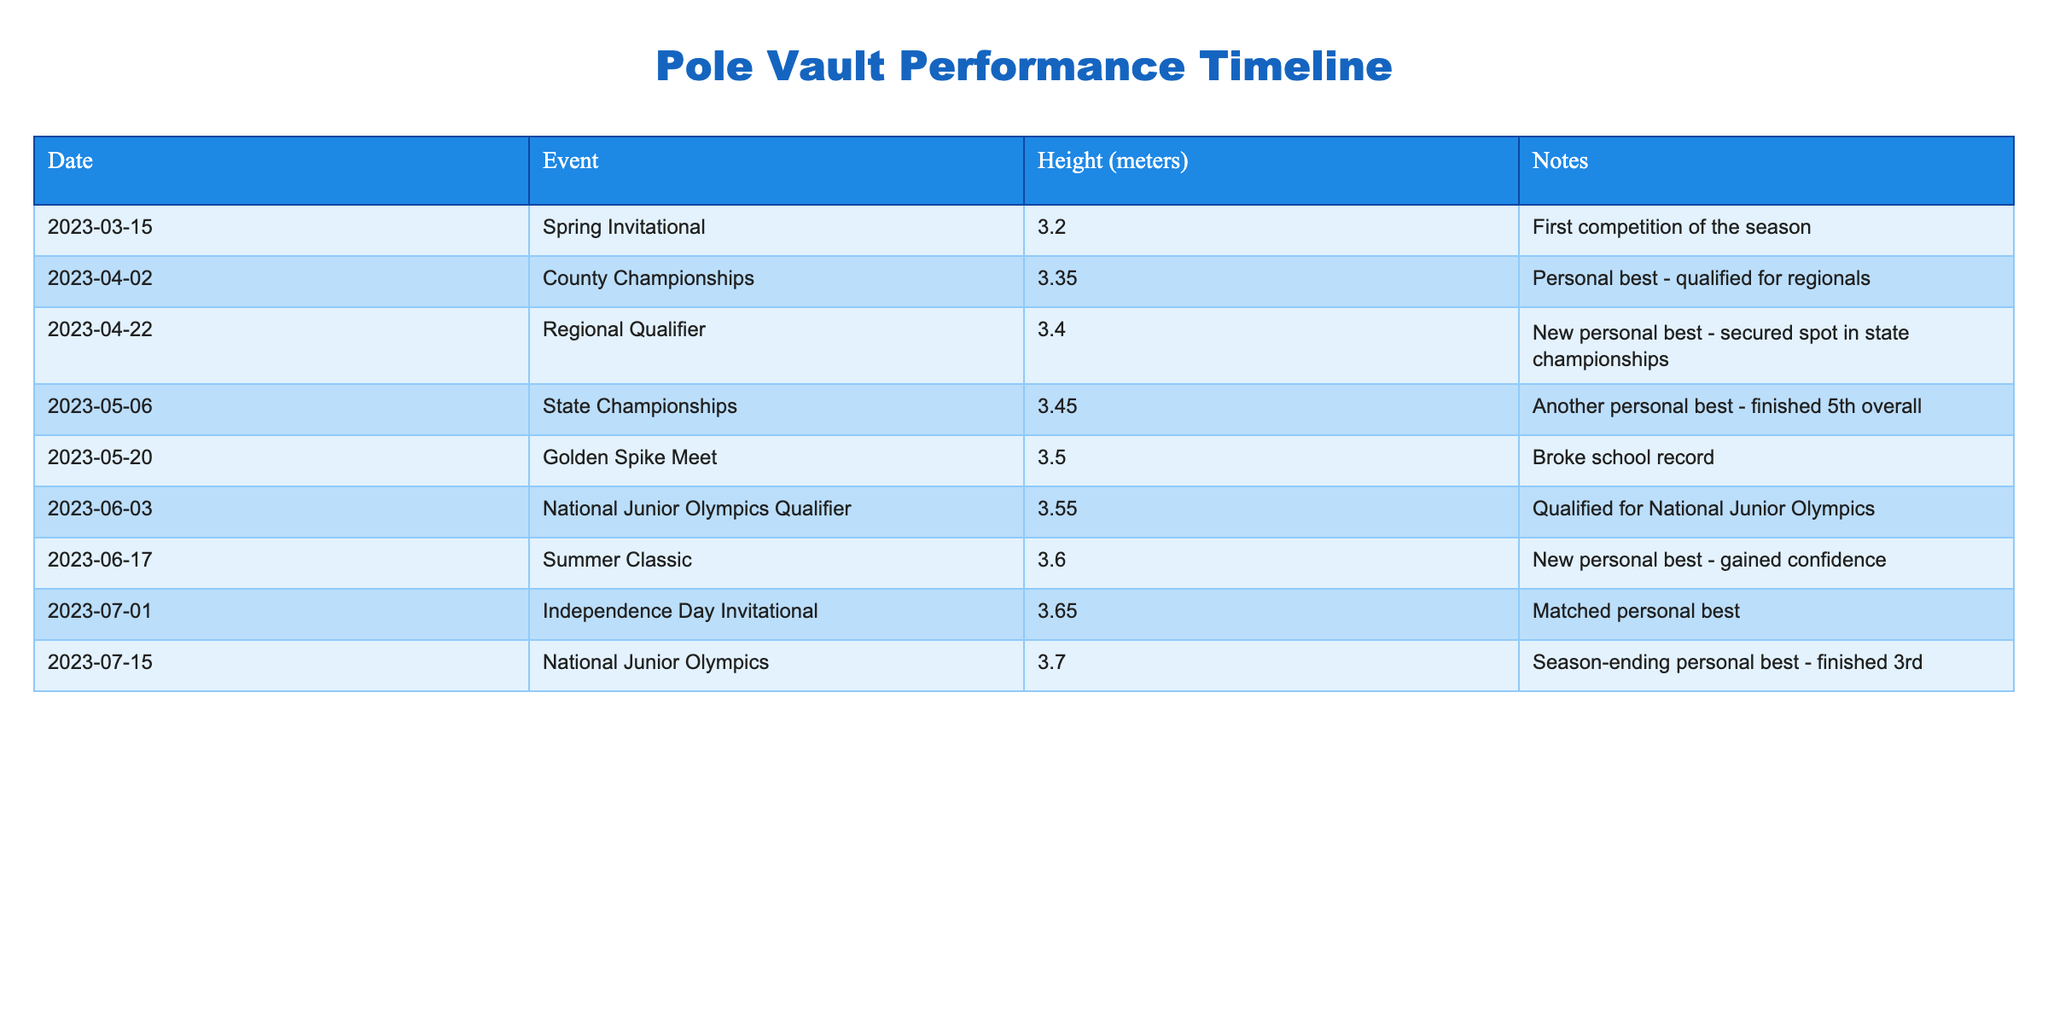What was the highest height achieved in the competitions? The highest height can be found by looking at the "Height (meters)" column. Scanning through the entries, the maximum value is 3.70 meters, which was achieved at the National Junior Olympics.
Answer: 3.70 meters How many personal best heights were recorded during the season? Counting the occurrences of "personal best" mentioned in the "Notes" column, there are four entries that state a personal best: County Championships (3.35), Regional Qualifier (3.40), State Championships (3.45), Summer Classic (3.60), and National Junior Olympics (3.70). So, there are a total of four personal bests.
Answer: 4 What is the difference in height between the first and last recorded competitions? The first competition's height on March 15 was 3.20 meters, and the last competition on July 15 was 3.70 meters. The difference is calculated as 3.70 - 3.20 = 0.50 meters.
Answer: 0.50 meters Did the athlete achieve a new personal best in the Spring Invitational? The Spring Invitational marks the first competition of the season, where the recorded height was 3.20 meters. There is no previous height to compare to, thus a new personal best was not achieved here as it was the initial record.
Answer: No What was the average height achieved across all competitions? To find the average, sum all the heights: (3.20 + 3.35 + 3.40 + 3.45 + 3.50 + 3.55 + 3.60 + 3.65 + 3.70) = 30.50 meters. Divide this sum by the number of competitions (9): 30.50 / 9 = approximately 3.39 meters.
Answer: 3.39 meters Which competition had the second highest height, and what was that height? In the list, the highest height of 3.70 meters was achieved at the National Junior Olympics. The second highest is 3.65 meters, recorded at the Independence Day Invitational.
Answer: Independence Day Invitational, 3.65 meters Was there a competition where the athlete matched their personal best? The table shows that at the Independence Day Invitational, the height of 3.65 meters was recorded as a match to a previous personal best, achieved earlier in the year.
Answer: Yes How many competitions had heights of 3.50 meters or higher? By counting the entries where the height is 3.50 meters or higher, we find there are six competitions: Golden Spike Meet (3.50), National Junior Olympics Qualifier (3.55), Summer Classic (3.60), Independence Day Invitational (3.65), and National Junior Olympics (3.70).
Answer: 6 